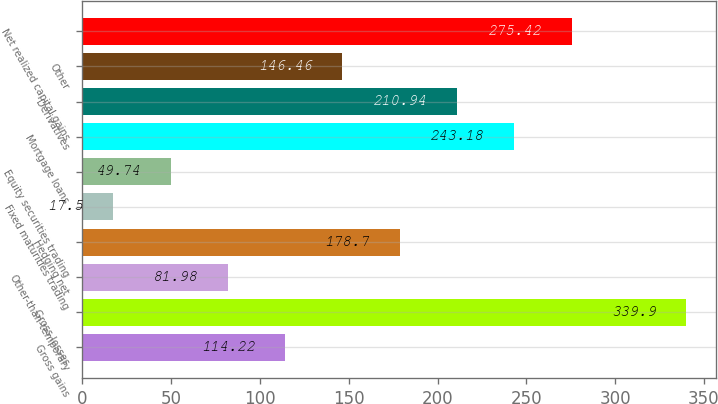<chart> <loc_0><loc_0><loc_500><loc_500><bar_chart><fcel>Gross gains<fcel>Gross losses<fcel>Other-than-temporary<fcel>Hedging net<fcel>Fixed maturities trading<fcel>Equity securities trading<fcel>Mortgage loans<fcel>Derivatives<fcel>Other<fcel>Net realized capital gains<nl><fcel>114.22<fcel>339.9<fcel>81.98<fcel>178.7<fcel>17.5<fcel>49.74<fcel>243.18<fcel>210.94<fcel>146.46<fcel>275.42<nl></chart> 